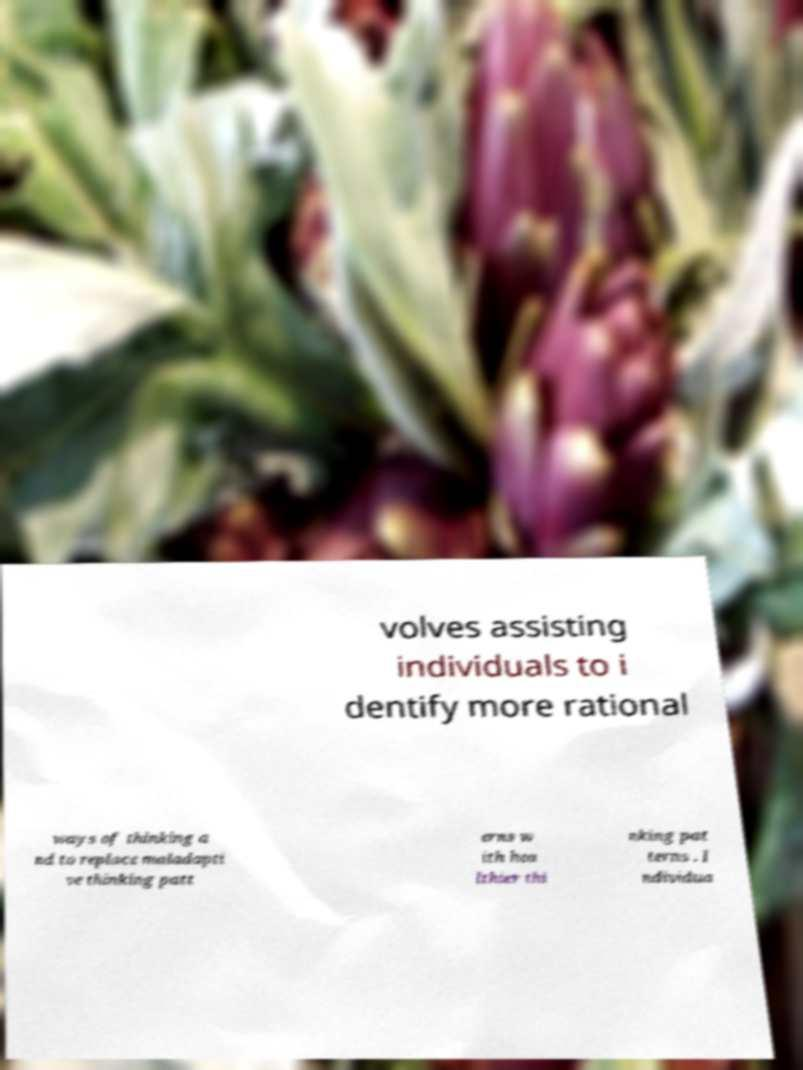Please read and relay the text visible in this image. What does it say? volves assisting individuals to i dentify more rational ways of thinking a nd to replace maladapti ve thinking patt erns w ith hea lthier thi nking pat terns . I ndividua 